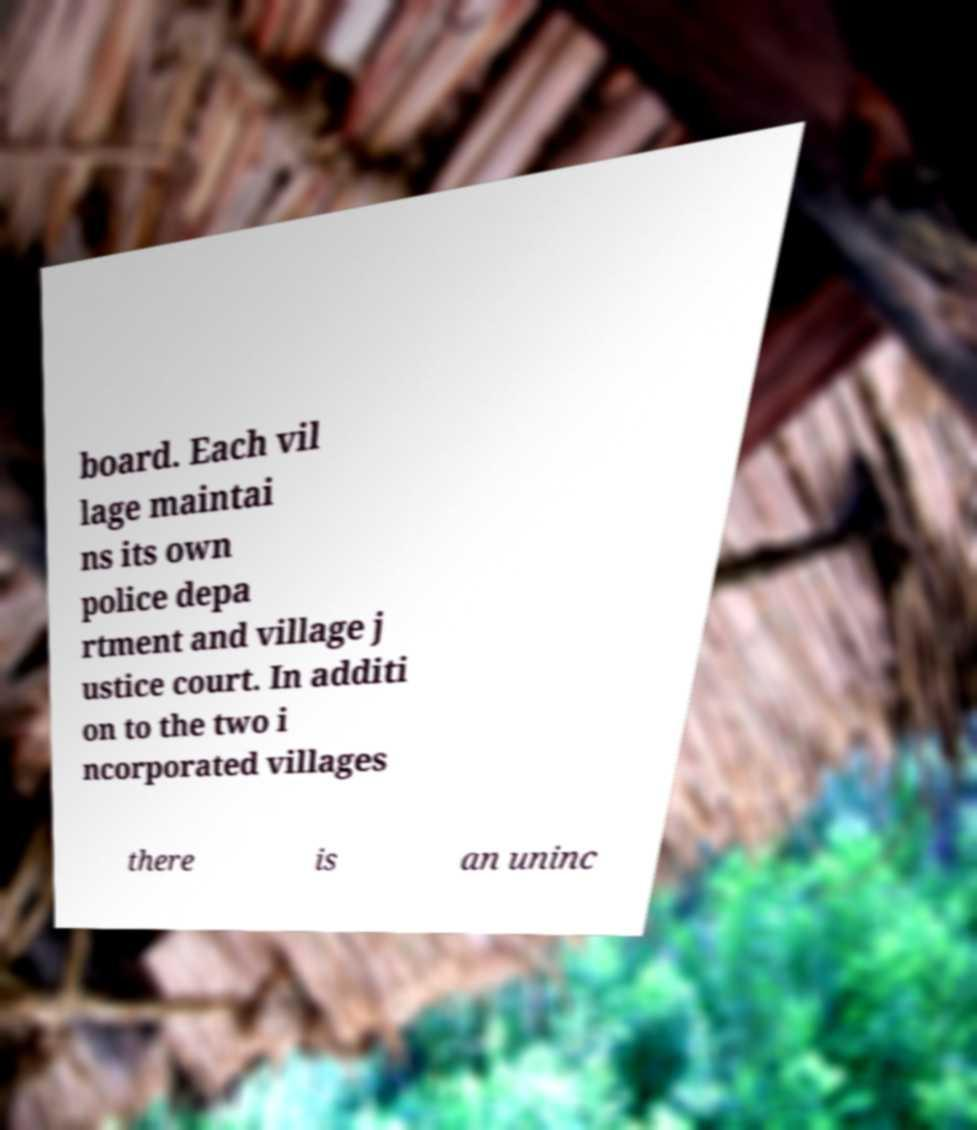What messages or text are displayed in this image? I need them in a readable, typed format. board. Each vil lage maintai ns its own police depa rtment and village j ustice court. In additi on to the two i ncorporated villages there is an uninc 